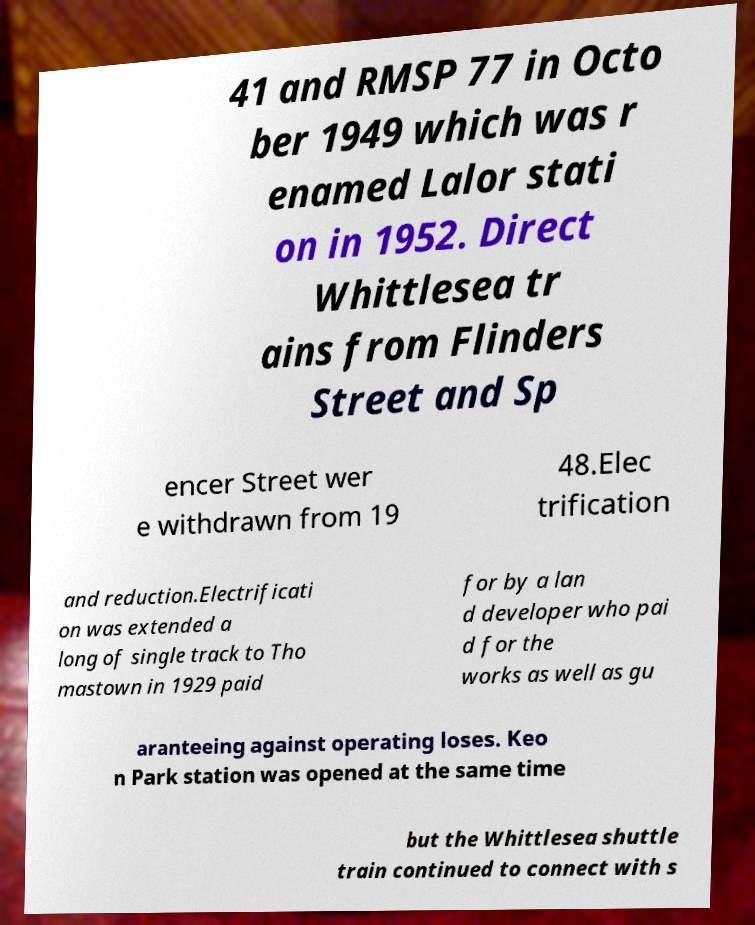Please read and relay the text visible in this image. What does it say? 41 and RMSP 77 in Octo ber 1949 which was r enamed Lalor stati on in 1952. Direct Whittlesea tr ains from Flinders Street and Sp encer Street wer e withdrawn from 19 48.Elec trification and reduction.Electrificati on was extended a long of single track to Tho mastown in 1929 paid for by a lan d developer who pai d for the works as well as gu aranteeing against operating loses. Keo n Park station was opened at the same time but the Whittlesea shuttle train continued to connect with s 